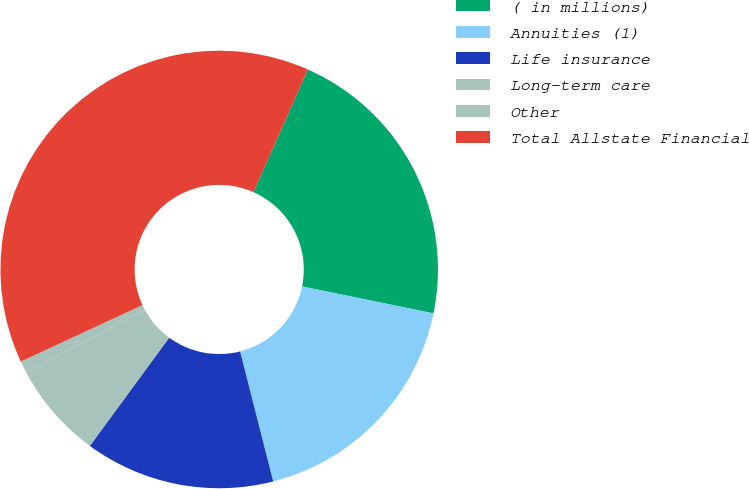Convert chart. <chart><loc_0><loc_0><loc_500><loc_500><pie_chart><fcel>( in millions)<fcel>Annuities (1)<fcel>Life insurance<fcel>Long-term care<fcel>Other<fcel>Total Allstate Financial<nl><fcel>21.57%<fcel>17.81%<fcel>14.04%<fcel>7.1%<fcel>0.91%<fcel>38.56%<nl></chart> 